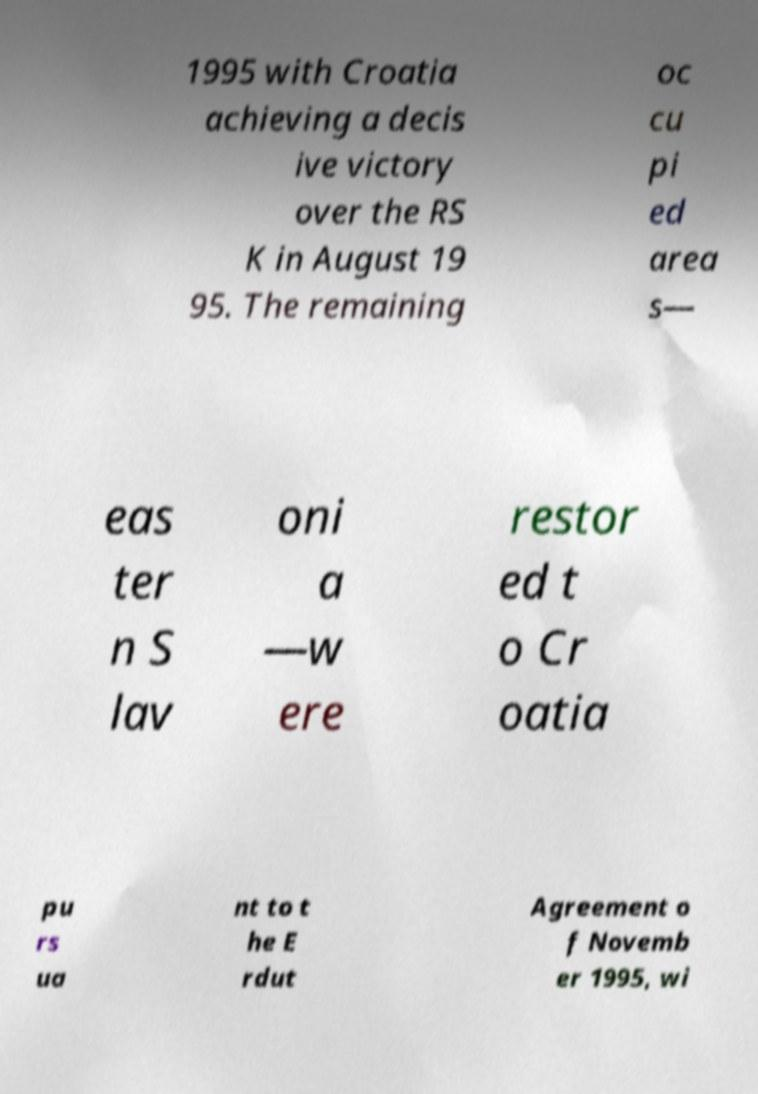For documentation purposes, I need the text within this image transcribed. Could you provide that? 1995 with Croatia achieving a decis ive victory over the RS K in August 19 95. The remaining oc cu pi ed area s— eas ter n S lav oni a —w ere restor ed t o Cr oatia pu rs ua nt to t he E rdut Agreement o f Novemb er 1995, wi 